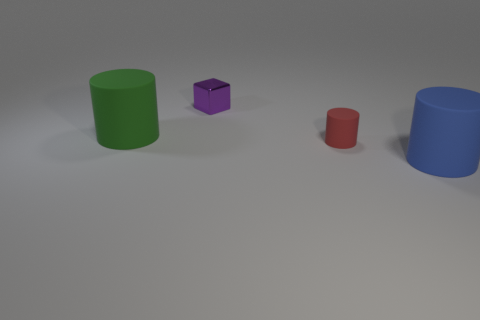There is a small thing that is to the left of the small red matte cylinder; what is its shape?
Your response must be concise. Cube. The red object that is the same shape as the blue rubber thing is what size?
Give a very brief answer. Small. Is there anything else that has the same shape as the small purple shiny thing?
Offer a very short reply. No. Is there a big rubber cylinder in front of the large rubber cylinder on the right side of the purple object?
Give a very brief answer. No. The other small rubber object that is the same shape as the blue matte thing is what color?
Give a very brief answer. Red. There is a large object that is to the right of the small cylinder that is in front of the object behind the big green rubber cylinder; what color is it?
Provide a succinct answer. Blue. Is the material of the small red thing the same as the green cylinder?
Make the answer very short. Yes. Do the small rubber object and the green thing have the same shape?
Keep it short and to the point. Yes. Is the number of tiny rubber things right of the tiny purple metal block the same as the number of big matte cylinders that are to the left of the blue cylinder?
Offer a very short reply. Yes. What is the color of the big object that is made of the same material as the blue cylinder?
Your answer should be very brief. Green. 